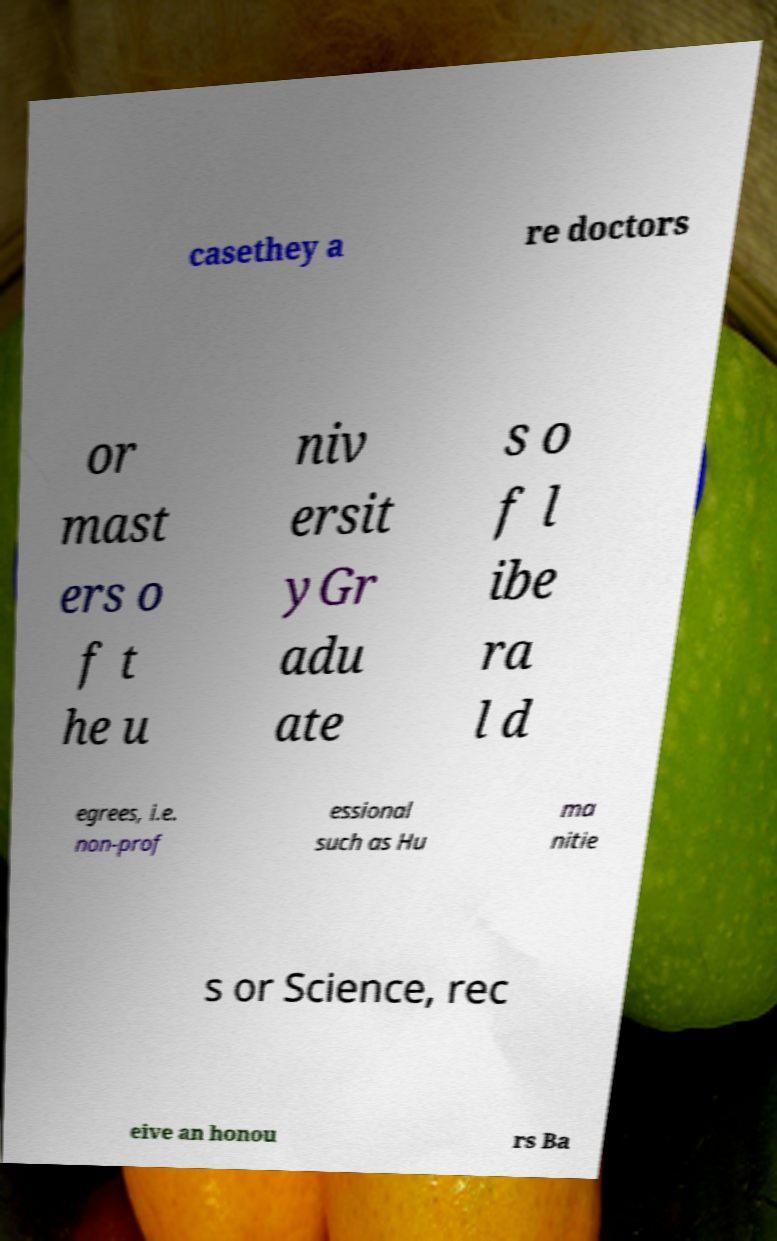I need the written content from this picture converted into text. Can you do that? casethey a re doctors or mast ers o f t he u niv ersit yGr adu ate s o f l ibe ra l d egrees, i.e. non-prof essional such as Hu ma nitie s or Science, rec eive an honou rs Ba 